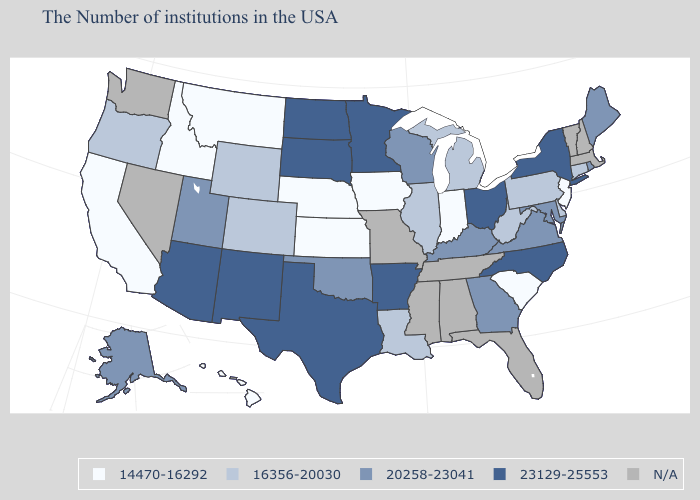What is the value of South Dakota?
Give a very brief answer. 23129-25553. What is the value of Tennessee?
Give a very brief answer. N/A. Name the states that have a value in the range 23129-25553?
Answer briefly. New York, North Carolina, Ohio, Arkansas, Minnesota, Texas, South Dakota, North Dakota, New Mexico, Arizona. What is the value of Utah?
Be succinct. 20258-23041. What is the value of Wisconsin?
Keep it brief. 20258-23041. What is the value of Montana?
Quick response, please. 14470-16292. What is the value of Oklahoma?
Short answer required. 20258-23041. Among the states that border Kentucky , which have the lowest value?
Write a very short answer. Indiana. Does Maryland have the highest value in the South?
Short answer required. No. Which states have the lowest value in the USA?
Concise answer only. New Jersey, South Carolina, Indiana, Iowa, Kansas, Nebraska, Montana, Idaho, California, Hawaii. Does the map have missing data?
Quick response, please. Yes. Does the map have missing data?
Answer briefly. Yes. Which states have the highest value in the USA?
Short answer required. New York, North Carolina, Ohio, Arkansas, Minnesota, Texas, South Dakota, North Dakota, New Mexico, Arizona. Name the states that have a value in the range N/A?
Short answer required. Massachusetts, New Hampshire, Vermont, Florida, Alabama, Tennessee, Mississippi, Missouri, Nevada, Washington. How many symbols are there in the legend?
Answer briefly. 5. 